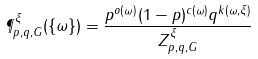Convert formula to latex. <formula><loc_0><loc_0><loc_500><loc_500>\P _ { p , q , G } ^ { \xi } ( \{ \omega \} ) = \frac { p ^ { o ( \omega ) } ( 1 - p ) ^ { c ( \omega ) } q ^ { k ( \omega , \xi ) } } { Z _ { p , q , G } ^ { \xi } }</formula> 